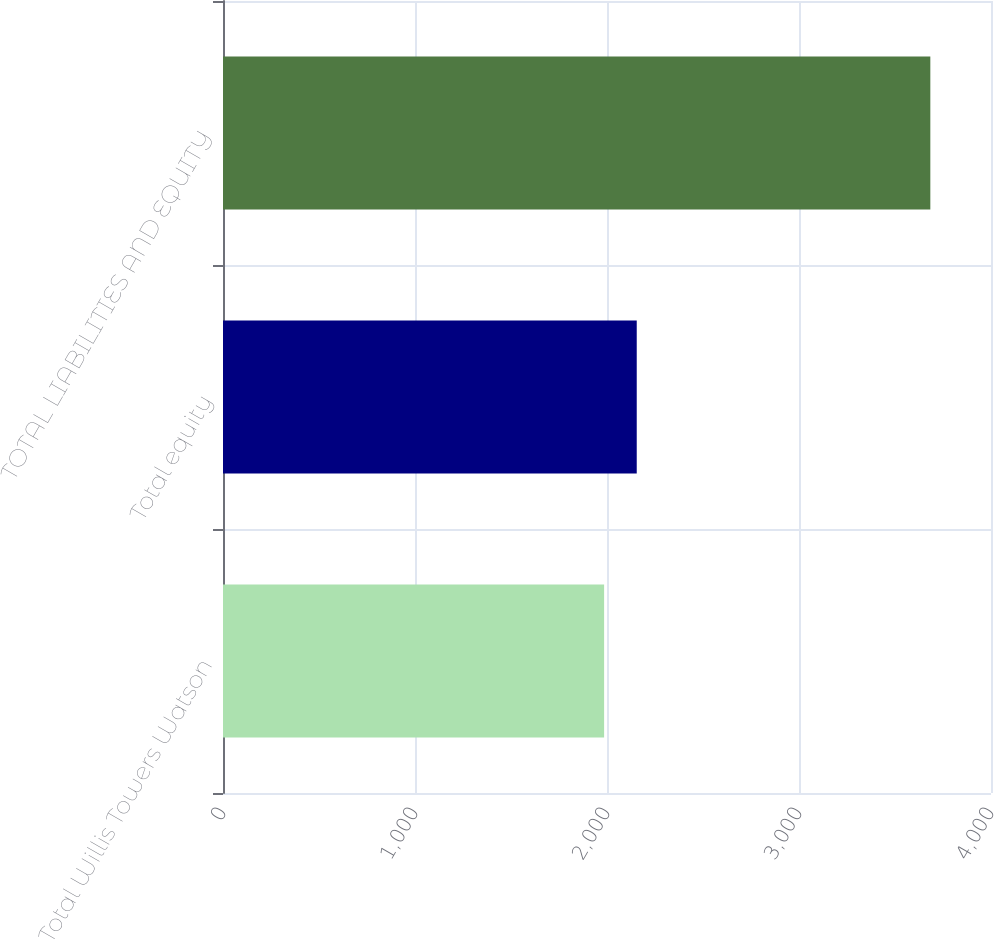<chart> <loc_0><loc_0><loc_500><loc_500><bar_chart><fcel>Total Willis Towers Watson<fcel>Total equity<fcel>TOTAL LIABILITIES AND EQUITY<nl><fcel>1985<fcel>2154.9<fcel>3684<nl></chart> 